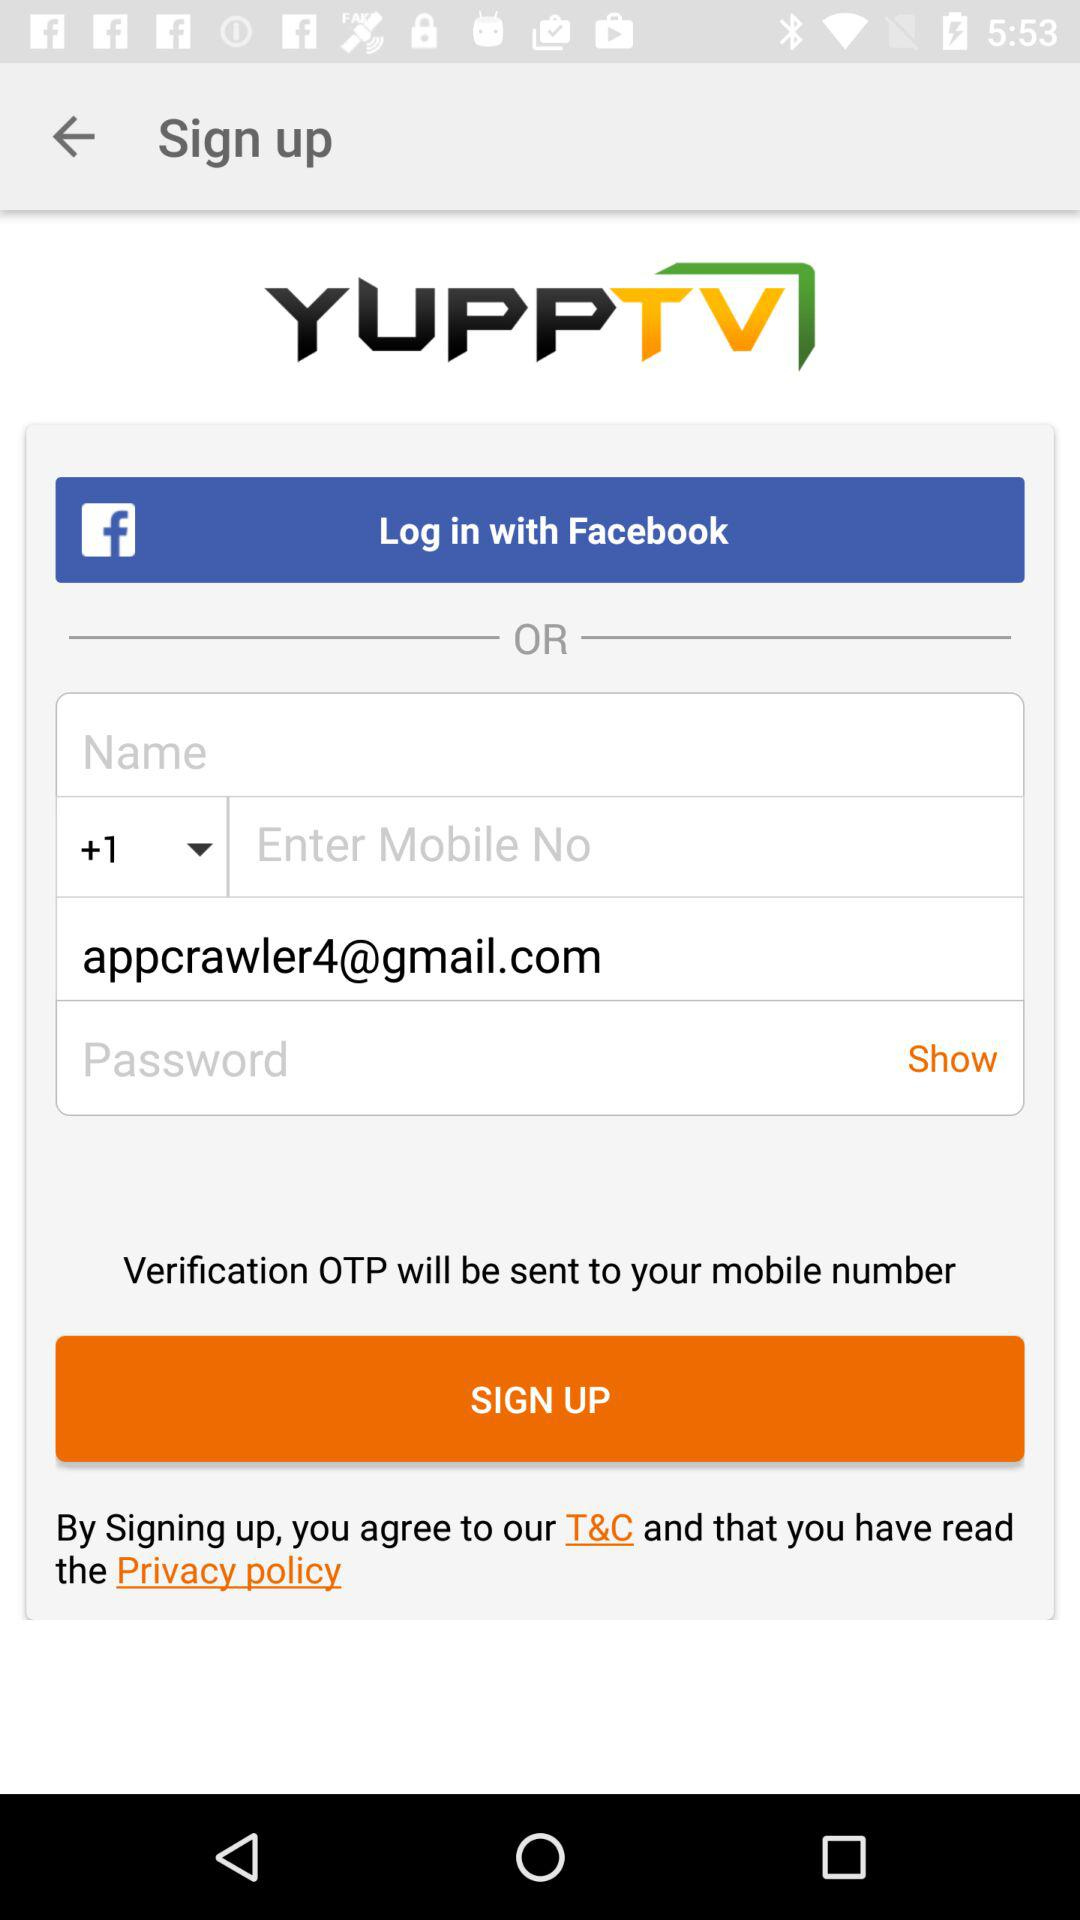Through which application can we sign up?
When the provided information is insufficient, respond with <no answer>. <no answer> 